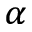<formula> <loc_0><loc_0><loc_500><loc_500>_ { \alpha }</formula> 